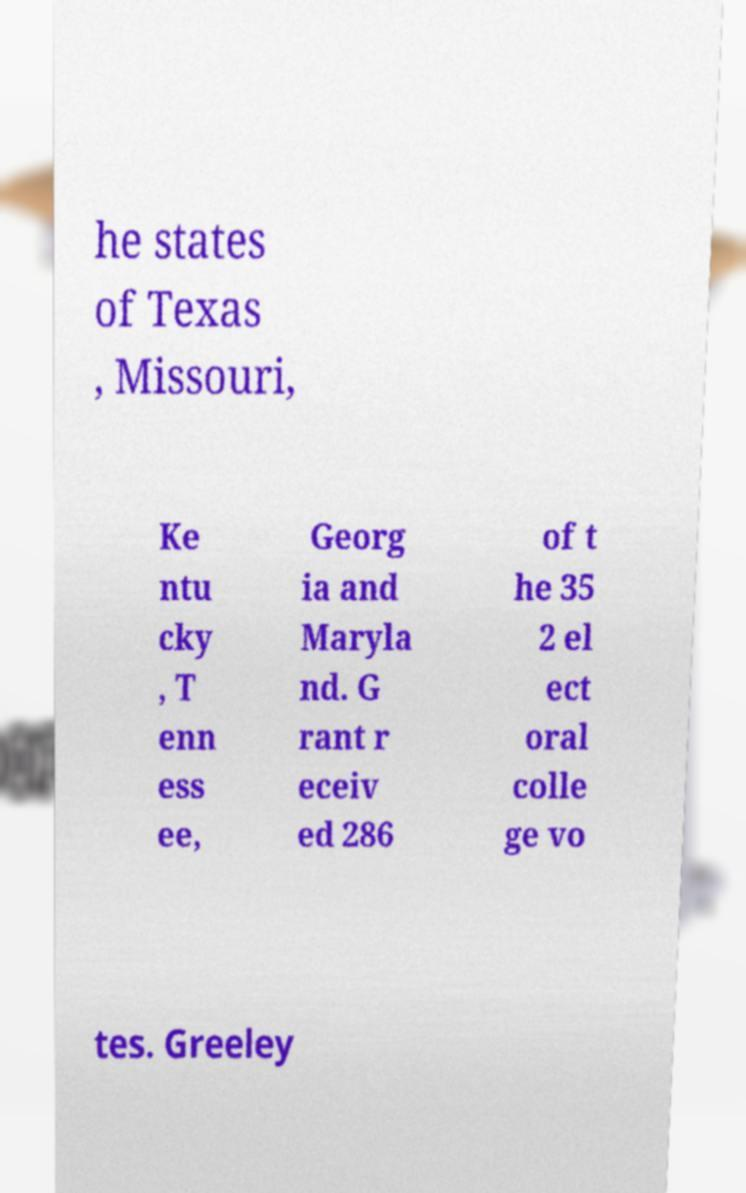Please identify and transcribe the text found in this image. he states of Texas , Missouri, Ke ntu cky , T enn ess ee, Georg ia and Maryla nd. G rant r eceiv ed 286 of t he 35 2 el ect oral colle ge vo tes. Greeley 